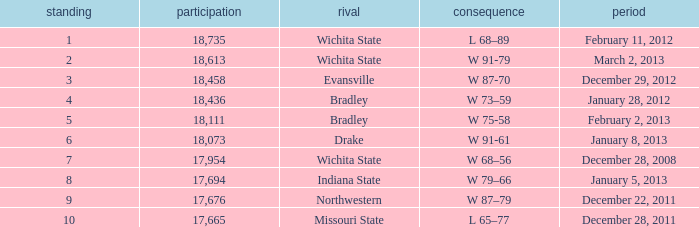What's the rank for February 11, 2012 with less than 18,735 in attendance? None. 